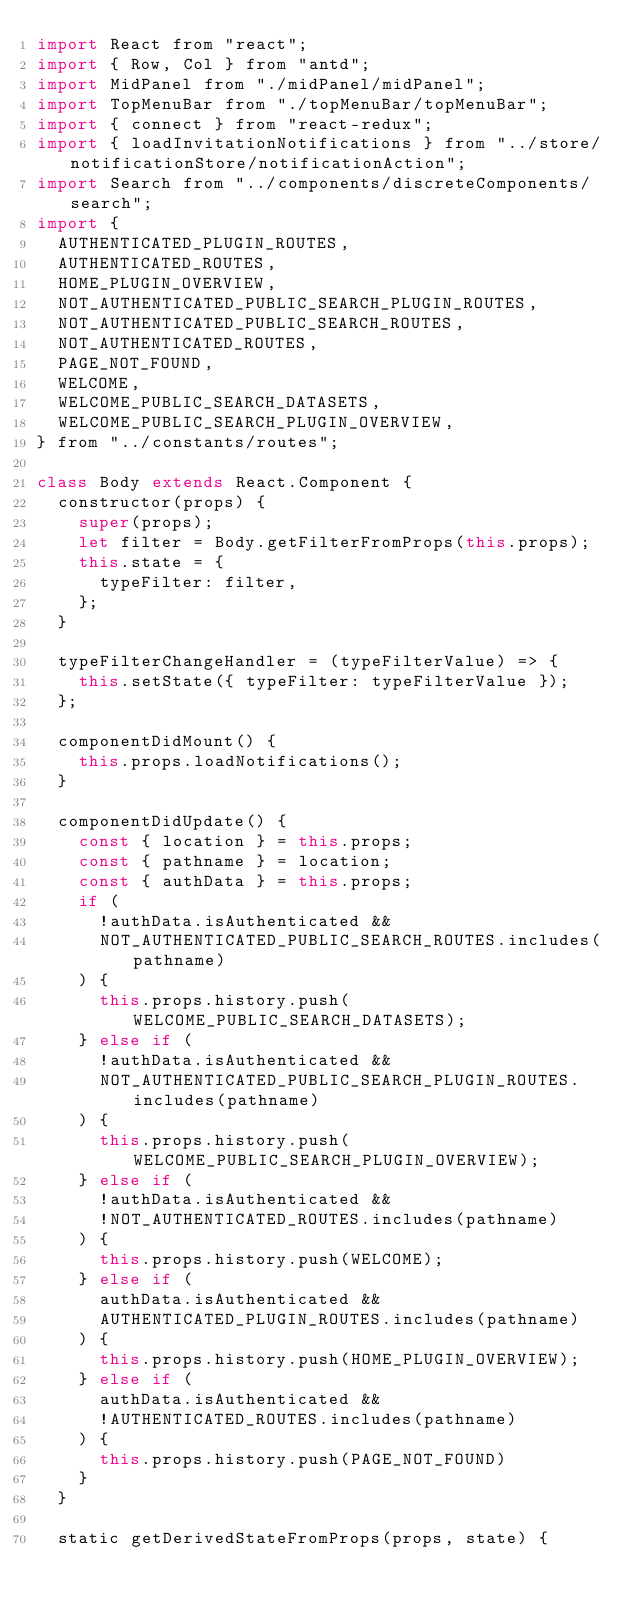Convert code to text. <code><loc_0><loc_0><loc_500><loc_500><_JavaScript_>import React from "react";
import { Row, Col } from "antd";
import MidPanel from "./midPanel/midPanel";
import TopMenuBar from "./topMenuBar/topMenuBar";
import { connect } from "react-redux";
import { loadInvitationNotifications } from "../store/notificationStore/notificationAction";
import Search from "../components/discreteComponents/search";
import {
  AUTHENTICATED_PLUGIN_ROUTES,
  AUTHENTICATED_ROUTES,
  HOME_PLUGIN_OVERVIEW,
  NOT_AUTHENTICATED_PUBLIC_SEARCH_PLUGIN_ROUTES,
  NOT_AUTHENTICATED_PUBLIC_SEARCH_ROUTES,
  NOT_AUTHENTICATED_ROUTES,
  PAGE_NOT_FOUND,
  WELCOME,
  WELCOME_PUBLIC_SEARCH_DATASETS,
  WELCOME_PUBLIC_SEARCH_PLUGIN_OVERVIEW,
} from "../constants/routes";

class Body extends React.Component {
  constructor(props) {
    super(props);
    let filter = Body.getFilterFromProps(this.props);
    this.state = {
      typeFilter: filter,
    };
  }

  typeFilterChangeHandler = (typeFilterValue) => {
    this.setState({ typeFilter: typeFilterValue });
  };

  componentDidMount() {
    this.props.loadNotifications();
  }

  componentDidUpdate() {
    const { location } = this.props;
    const { pathname } = location;
    const { authData } = this.props;
    if (
      !authData.isAuthenticated &&
      NOT_AUTHENTICATED_PUBLIC_SEARCH_ROUTES.includes(pathname)
    ) {
      this.props.history.push(WELCOME_PUBLIC_SEARCH_DATASETS);
    } else if (
      !authData.isAuthenticated &&
      NOT_AUTHENTICATED_PUBLIC_SEARCH_PLUGIN_ROUTES.includes(pathname)
    ) {
      this.props.history.push(WELCOME_PUBLIC_SEARCH_PLUGIN_OVERVIEW);
    } else if (
      !authData.isAuthenticated &&
      !NOT_AUTHENTICATED_ROUTES.includes(pathname) 
    ) {
      this.props.history.push(WELCOME);
    } else if (
      authData.isAuthenticated &&
      AUTHENTICATED_PLUGIN_ROUTES.includes(pathname)
    ) {
      this.props.history.push(HOME_PLUGIN_OVERVIEW);
    } else if (
      authData.isAuthenticated &&
      !AUTHENTICATED_ROUTES.includes(pathname)
    ) {
      this.props.history.push(PAGE_NOT_FOUND)
    }
  }

  static getDerivedStateFromProps(props, state) {</code> 